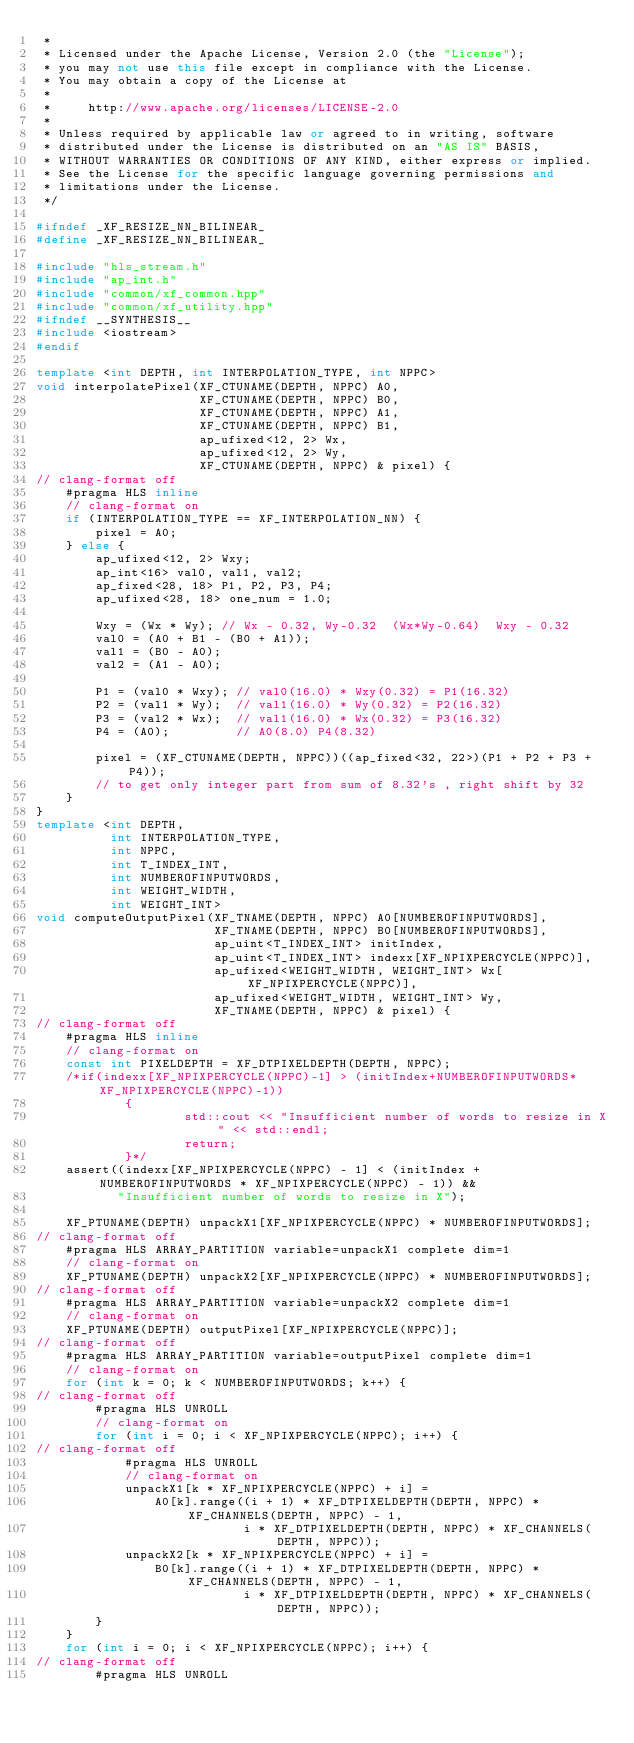<code> <loc_0><loc_0><loc_500><loc_500><_C++_> *
 * Licensed under the Apache License, Version 2.0 (the "License");
 * you may not use this file except in compliance with the License.
 * You may obtain a copy of the License at
 *
 *     http://www.apache.org/licenses/LICENSE-2.0
 *
 * Unless required by applicable law or agreed to in writing, software
 * distributed under the License is distributed on an "AS IS" BASIS,
 * WITHOUT WARRANTIES OR CONDITIONS OF ANY KIND, either express or implied.
 * See the License for the specific language governing permissions and
 * limitations under the License.
 */

#ifndef _XF_RESIZE_NN_BILINEAR_
#define _XF_RESIZE_NN_BILINEAR_

#include "hls_stream.h"
#include "ap_int.h"
#include "common/xf_common.hpp"
#include "common/xf_utility.hpp"
#ifndef __SYNTHESIS__
#include <iostream>
#endif

template <int DEPTH, int INTERPOLATION_TYPE, int NPPC>
void interpolatePixel(XF_CTUNAME(DEPTH, NPPC) A0,
                      XF_CTUNAME(DEPTH, NPPC) B0,
                      XF_CTUNAME(DEPTH, NPPC) A1,
                      XF_CTUNAME(DEPTH, NPPC) B1,
                      ap_ufixed<12, 2> Wx,
                      ap_ufixed<12, 2> Wy,
                      XF_CTUNAME(DEPTH, NPPC) & pixel) {
// clang-format off
    #pragma HLS inline
    // clang-format on
    if (INTERPOLATION_TYPE == XF_INTERPOLATION_NN) {
        pixel = A0;
    } else {
        ap_ufixed<12, 2> Wxy;
        ap_int<16> val0, val1, val2;
        ap_fixed<28, 18> P1, P2, P3, P4;
        ap_ufixed<28, 18> one_num = 1.0;

        Wxy = (Wx * Wy); // Wx - 0.32, Wy-0.32  (Wx*Wy-0.64)  Wxy - 0.32
        val0 = (A0 + B1 - (B0 + A1));
        val1 = (B0 - A0);
        val2 = (A1 - A0);

        P1 = (val0 * Wxy); // val0(16.0) * Wxy(0.32) = P1(16.32)
        P2 = (val1 * Wy);  // val1(16.0) * Wy(0.32) = P2(16.32)
        P3 = (val2 * Wx);  // val1(16.0) * Wx(0.32) = P3(16.32)
        P4 = (A0);         // A0(8.0) P4(8.32)

        pixel = (XF_CTUNAME(DEPTH, NPPC))((ap_fixed<32, 22>)(P1 + P2 + P3 + P4));
        // to get only integer part from sum of 8.32's , right shift by 32
    }
}
template <int DEPTH,
          int INTERPOLATION_TYPE,
          int NPPC,
          int T_INDEX_INT,
          int NUMBEROFINPUTWORDS,
          int WEIGHT_WIDTH,
          int WEIGHT_INT>
void computeOutputPixel(XF_TNAME(DEPTH, NPPC) A0[NUMBEROFINPUTWORDS],
                        XF_TNAME(DEPTH, NPPC) B0[NUMBEROFINPUTWORDS],
                        ap_uint<T_INDEX_INT> initIndex,
                        ap_uint<T_INDEX_INT> indexx[XF_NPIXPERCYCLE(NPPC)],
                        ap_ufixed<WEIGHT_WIDTH, WEIGHT_INT> Wx[XF_NPIXPERCYCLE(NPPC)],
                        ap_ufixed<WEIGHT_WIDTH, WEIGHT_INT> Wy,
                        XF_TNAME(DEPTH, NPPC) & pixel) {
// clang-format off
    #pragma HLS inline
    // clang-format on
    const int PIXELDEPTH = XF_DTPIXELDEPTH(DEPTH, NPPC);
    /*if(indexx[XF_NPIXPERCYCLE(NPPC)-1] > (initIndex+NUMBEROFINPUTWORDS*XF_NPIXPERCYCLE(NPPC)-1))
            {
                    std::cout << "Insufficient number of words to resize in X" << std::endl;
                    return;
            }*/
    assert((indexx[XF_NPIXPERCYCLE(NPPC) - 1] < (initIndex + NUMBEROFINPUTWORDS * XF_NPIXPERCYCLE(NPPC) - 1)) &&
           "Insufficient number of words to resize in X");

    XF_PTUNAME(DEPTH) unpackX1[XF_NPIXPERCYCLE(NPPC) * NUMBEROFINPUTWORDS];
// clang-format off
    #pragma HLS ARRAY_PARTITION variable=unpackX1 complete dim=1
    // clang-format on
    XF_PTUNAME(DEPTH) unpackX2[XF_NPIXPERCYCLE(NPPC) * NUMBEROFINPUTWORDS];
// clang-format off
    #pragma HLS ARRAY_PARTITION variable=unpackX2 complete dim=1
    // clang-format on
    XF_PTUNAME(DEPTH) outputPixel[XF_NPIXPERCYCLE(NPPC)];
// clang-format off
    #pragma HLS ARRAY_PARTITION variable=outputPixel complete dim=1
    // clang-format on
    for (int k = 0; k < NUMBEROFINPUTWORDS; k++) {
// clang-format off
        #pragma HLS UNROLL
        // clang-format on
        for (int i = 0; i < XF_NPIXPERCYCLE(NPPC); i++) {
// clang-format off
            #pragma HLS UNROLL
            // clang-format on
            unpackX1[k * XF_NPIXPERCYCLE(NPPC) + i] =
                A0[k].range((i + 1) * XF_DTPIXELDEPTH(DEPTH, NPPC) * XF_CHANNELS(DEPTH, NPPC) - 1,
                            i * XF_DTPIXELDEPTH(DEPTH, NPPC) * XF_CHANNELS(DEPTH, NPPC));
            unpackX2[k * XF_NPIXPERCYCLE(NPPC) + i] =
                B0[k].range((i + 1) * XF_DTPIXELDEPTH(DEPTH, NPPC) * XF_CHANNELS(DEPTH, NPPC) - 1,
                            i * XF_DTPIXELDEPTH(DEPTH, NPPC) * XF_CHANNELS(DEPTH, NPPC));
        }
    }
    for (int i = 0; i < XF_NPIXPERCYCLE(NPPC); i++) {
// clang-format off
        #pragma HLS UNROLL</code> 